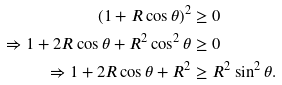Convert formula to latex. <formula><loc_0><loc_0><loc_500><loc_500>( 1 + R \cos \theta ) ^ { 2 } & \geq 0 \\ \Rightarrow 1 + 2 R \cos \theta + R ^ { 2 } \cos ^ { 2 } \theta & \geq 0 \\ \Rightarrow 1 + 2 R \cos \theta + R ^ { 2 } & \geq R ^ { 2 } \sin ^ { 2 } \theta .</formula> 